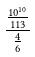<formula> <loc_0><loc_0><loc_500><loc_500>\frac { \frac { 1 0 ^ { 1 0 } } { 1 1 3 } } { \frac { 4 } { 6 } }</formula> 